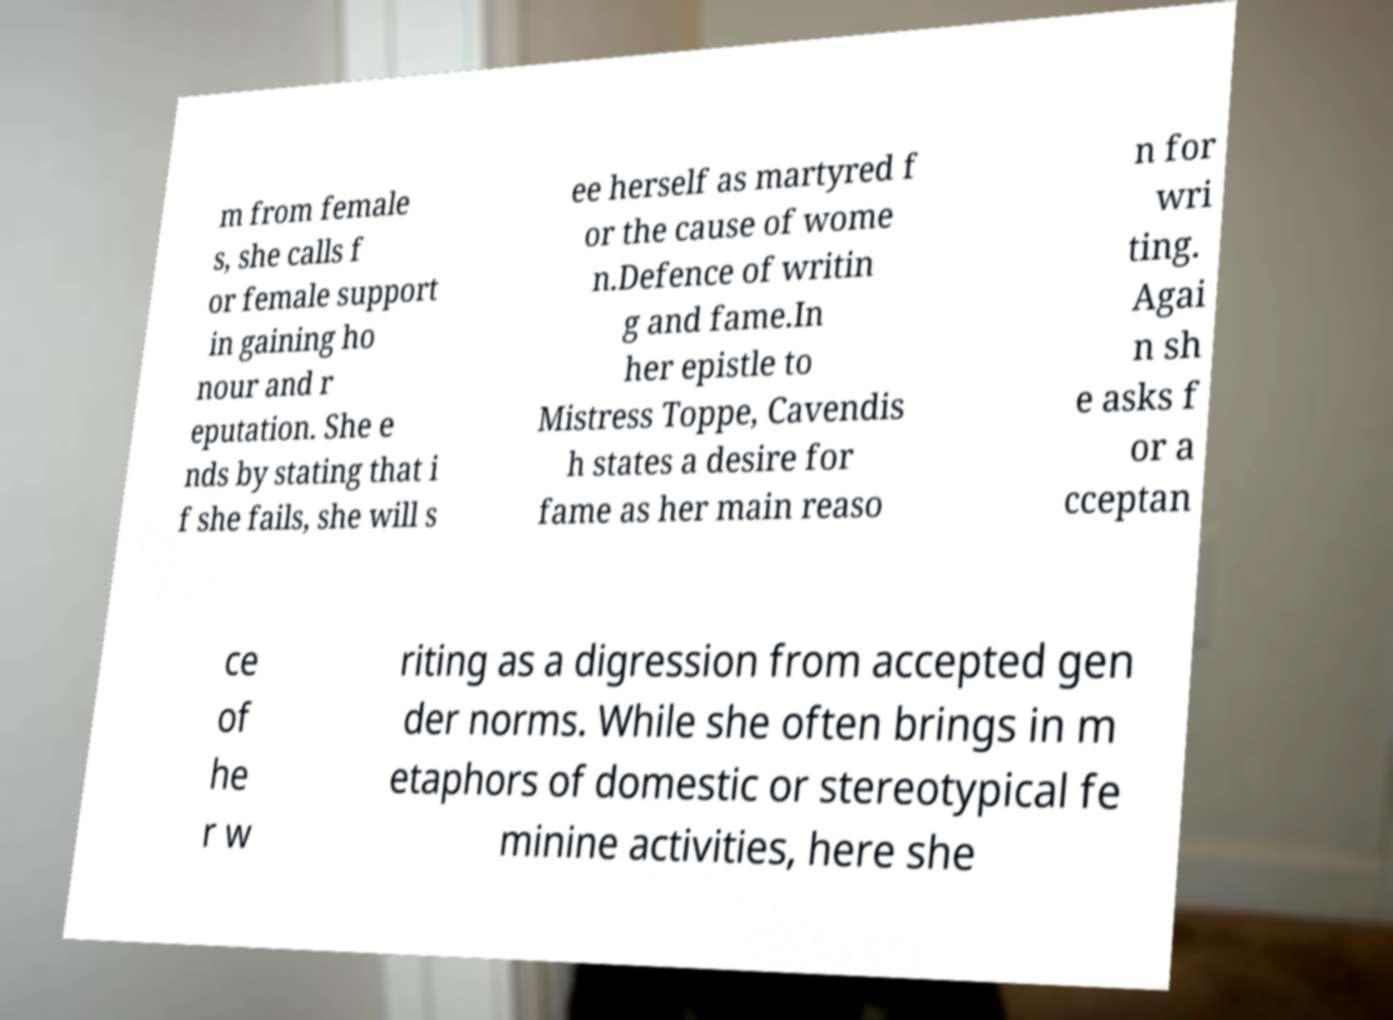I need the written content from this picture converted into text. Can you do that? m from female s, she calls f or female support in gaining ho nour and r eputation. She e nds by stating that i f she fails, she will s ee herself as martyred f or the cause of wome n.Defence of writin g and fame.In her epistle to Mistress Toppe, Cavendis h states a desire for fame as her main reaso n for wri ting. Agai n sh e asks f or a cceptan ce of he r w riting as a digression from accepted gen der norms. While she often brings in m etaphors of domestic or stereotypical fe minine activities, here she 